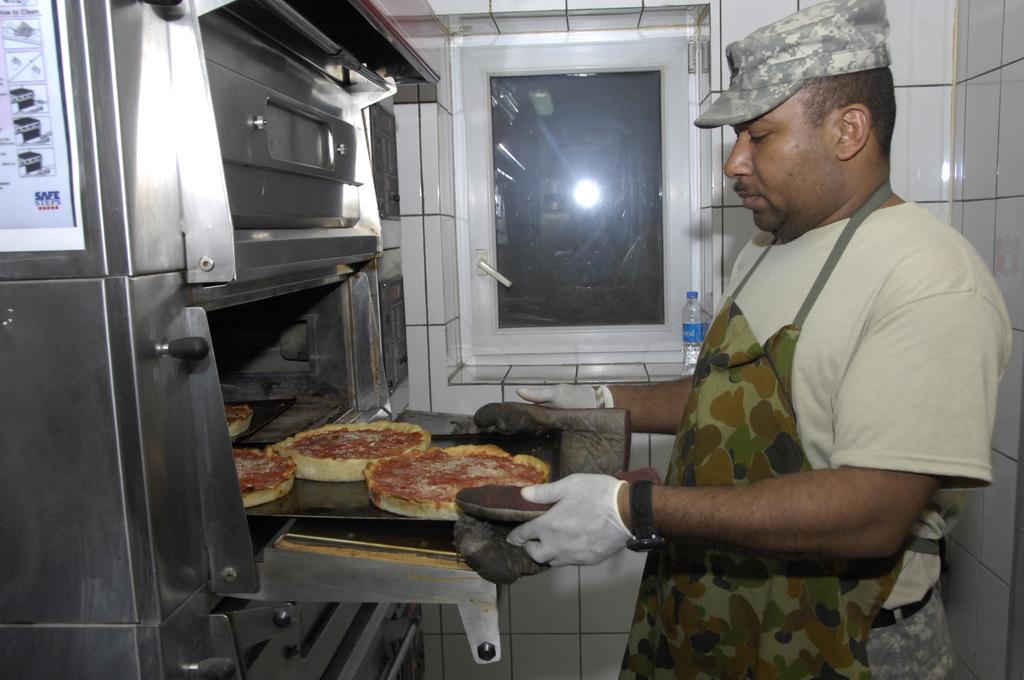What kind of steps on the sign?
Your answer should be compact. Safe. 